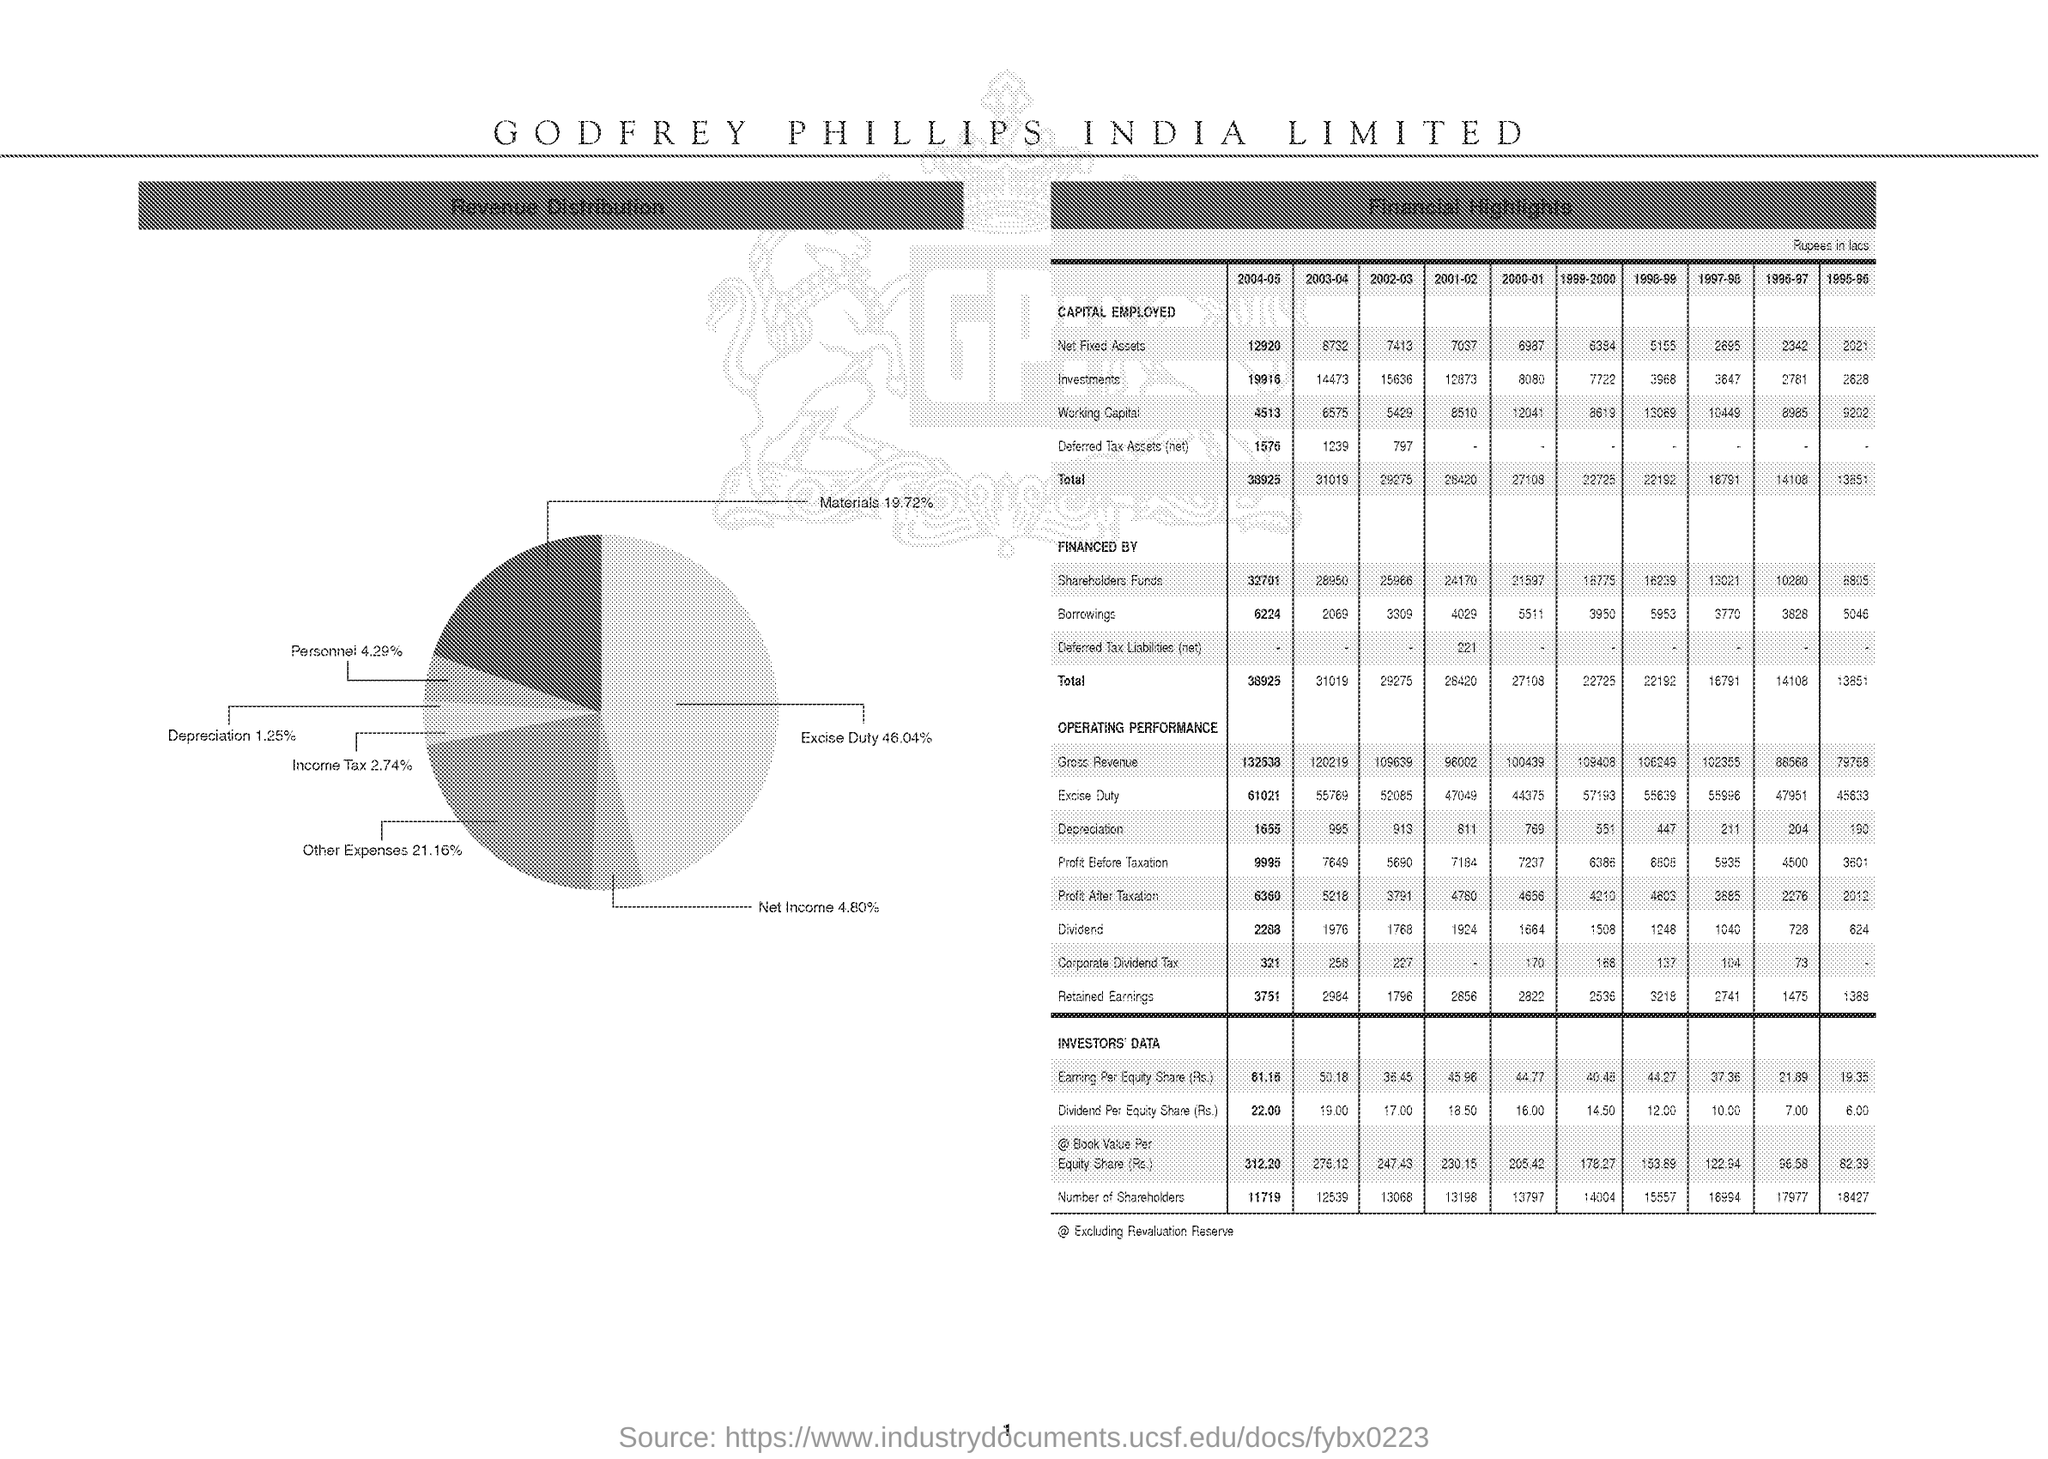List a handful of essential elements in this visual. The excise duty percentage was represented in a pie chart, and the chart showed that the excise duty amounted to 46.04% of the total tax. The total capital employed in 2004-05 was 38,925. 